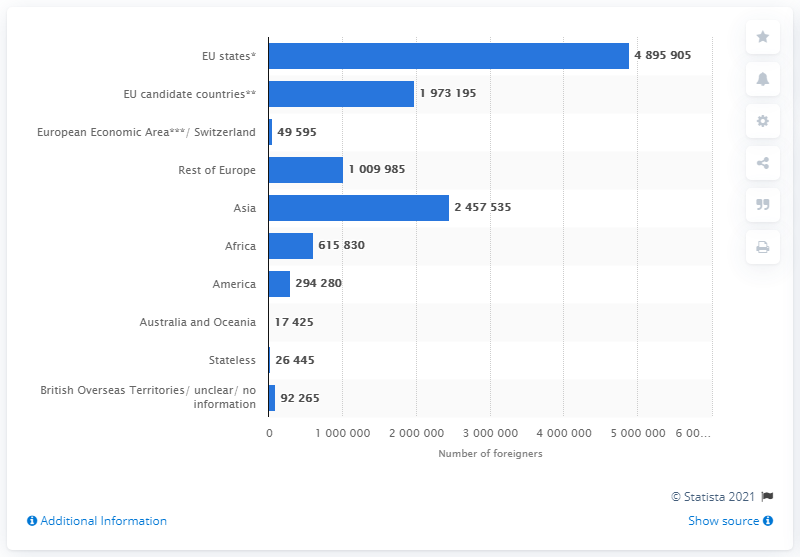Identify some key points in this picture. In 2020, there were approximately 48,959,050 EU nationals living in Germany. 